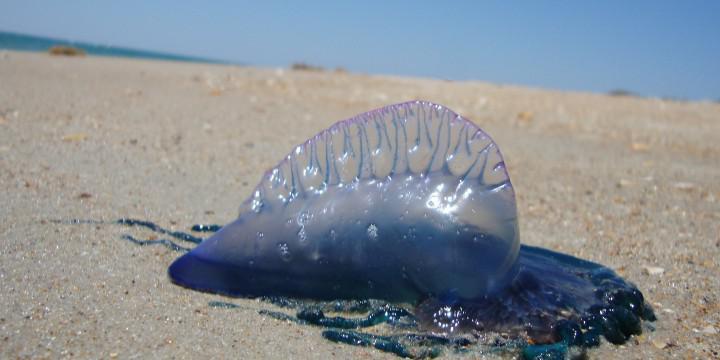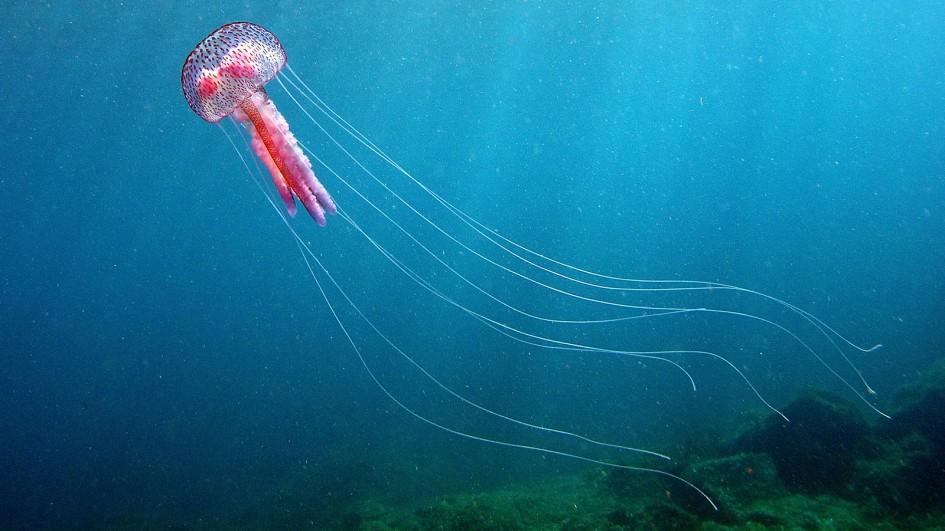The first image is the image on the left, the second image is the image on the right. For the images shown, is this caption "There is a warm-coloured jellyfish in the right image with a darker blue almost solid water background." true? Answer yes or no. No. 